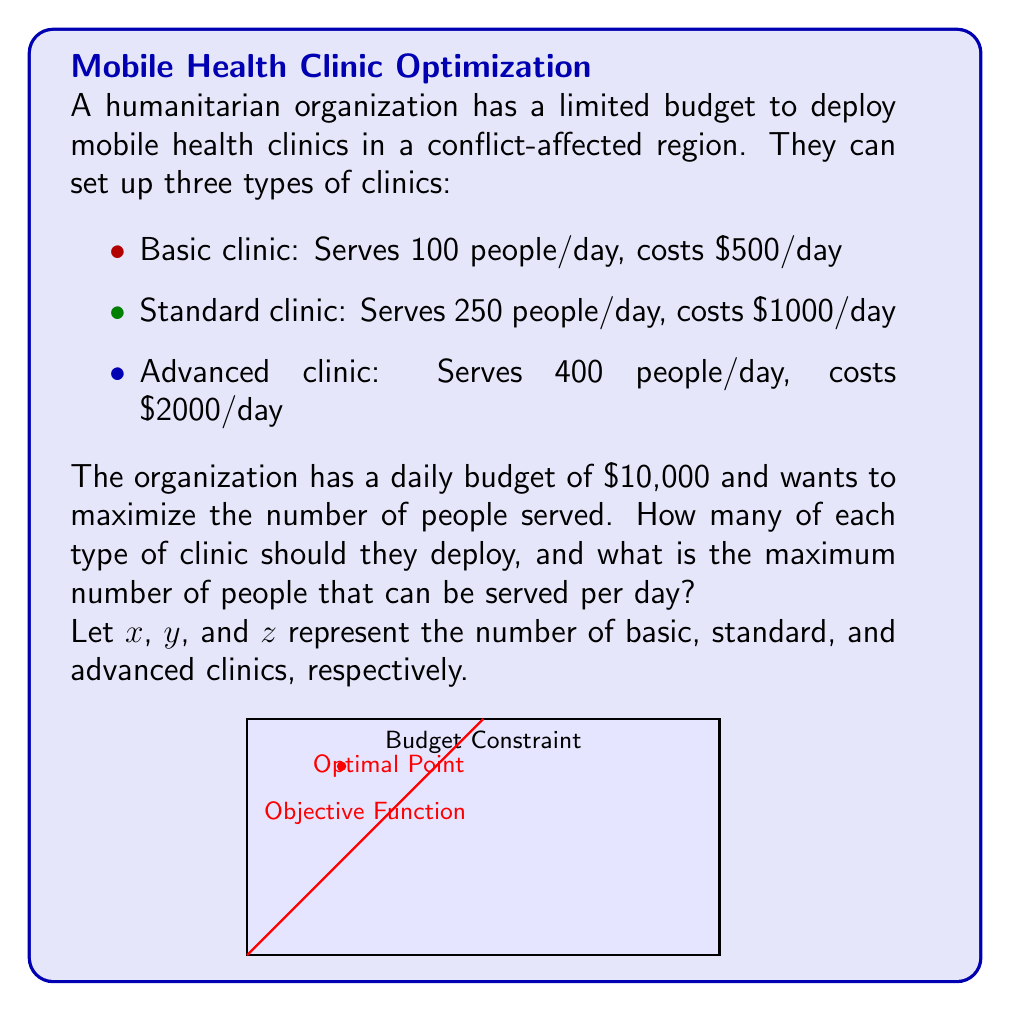Solve this math problem. Let's approach this step-by-step:

1) First, we need to set up our objective function. We want to maximize the number of people served:

   Maximize: $100x + 250y + 400z$

2) Next, we have our constraint, which is the budget:

   $500x + 1000y + 2000z \leq 10000$

3) We also need non-negativity constraints:

   $x, y, z \geq 0$ and $x, y, z$ are integers

4) This is an integer linear programming problem. We can solve it using the simplex method and then rounding down to the nearest integer.

5) Using a solver or graphical method, we find that the optimal solution is:

   $x = 0$ (Basic clinics)
   $y = 4$ (Standard clinics)
   $z = 3$ (Advanced clinics)

6) We can verify this solution:
   Cost: $0(500) + 4(1000) + 3(2000) = 10000$, which meets our budget constraint.

7) The number of people served with this configuration is:
   $0(100) + 4(250) + 3(400) = 2200$ people per day

This solution maximizes the number of people served while staying within the budget constraint.
Answer: 4 Standard clinics, 3 Advanced clinics; 2200 people served per day 